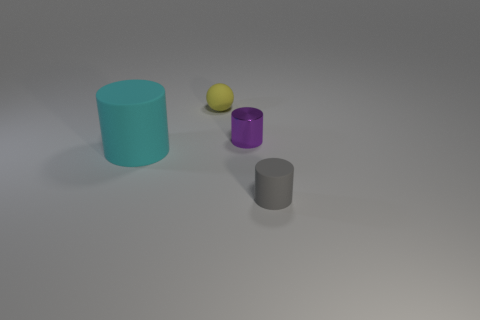How many metal things are large cyan objects or tiny yellow balls?
Make the answer very short. 0. There is a rubber cylinder that is on the left side of the small rubber object on the right side of the metal cylinder; is there a tiny metallic cylinder to the left of it?
Your answer should be compact. No. What color is the ball?
Offer a very short reply. Yellow. There is a small object to the left of the small metal cylinder; is it the same shape as the purple metal object?
Your response must be concise. No. What number of things are purple matte cylinders or big cyan rubber cylinders that are on the left side of the purple shiny cylinder?
Provide a short and direct response. 1. Is the material of the cylinder that is in front of the big rubber object the same as the small yellow object?
Offer a terse response. Yes. Is there anything else that is the same size as the cyan matte cylinder?
Ensure brevity in your answer.  No. What material is the thing that is to the left of the small thing behind the small purple cylinder?
Your answer should be very brief. Rubber. Are there more yellow balls in front of the yellow rubber object than small purple shiny things to the right of the shiny cylinder?
Provide a succinct answer. No. What size is the yellow matte sphere?
Your answer should be very brief. Small. 